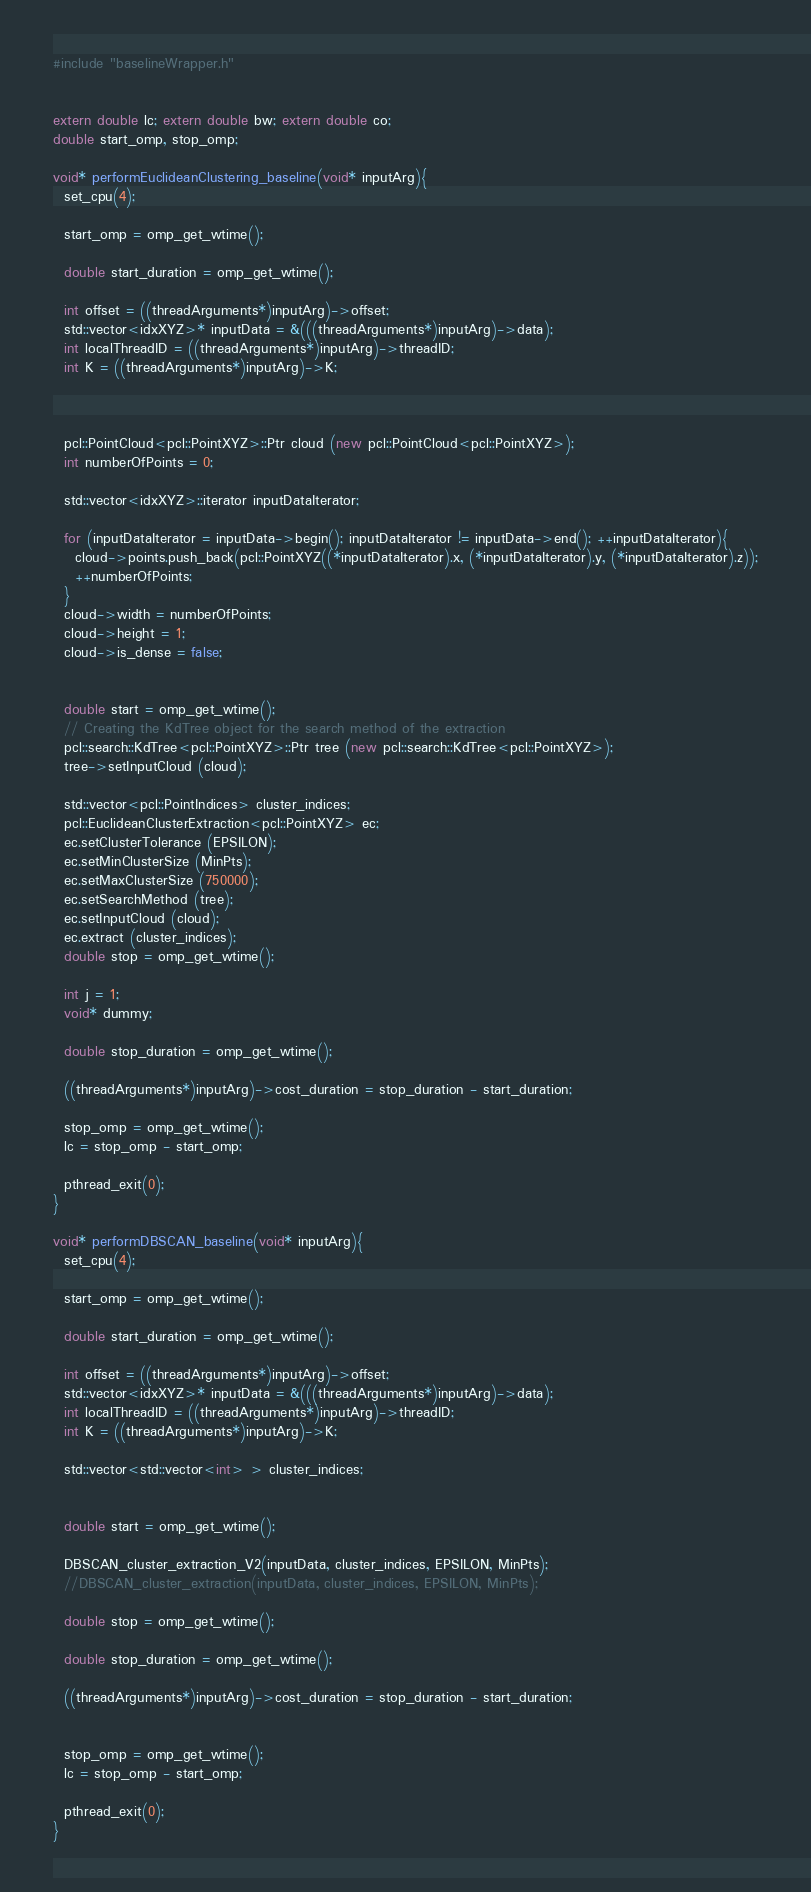Convert code to text. <code><loc_0><loc_0><loc_500><loc_500><_C++_>#include "baselineWrapper.h"


extern double lc; extern double bw; extern double co;
double start_omp, stop_omp;

void* performEuclideanClustering_baseline(void* inputArg){
  set_cpu(4);

  start_omp = omp_get_wtime();
  
  double start_duration = omp_get_wtime();
  
  int offset = ((threadArguments*)inputArg)->offset;
  std::vector<idxXYZ>* inputData = &(((threadArguments*)inputArg)->data);
  int localThreadID = ((threadArguments*)inputArg)->threadID;
  int K = ((threadArguments*)inputArg)->K;


  
  pcl::PointCloud<pcl::PointXYZ>::Ptr cloud (new pcl::PointCloud<pcl::PointXYZ>);
  int numberOfPoints = 0;

  std::vector<idxXYZ>::iterator inputDataIterator;

  for (inputDataIterator = inputData->begin(); inputDataIterator != inputData->end(); ++inputDataIterator){
    cloud->points.push_back(pcl::PointXYZ((*inputDataIterator).x, (*inputDataIterator).y, (*inputDataIterator).z));
    ++numberOfPoints;    
  }
  cloud->width = numberOfPoints; 
  cloud->height = 1;
  cloud->is_dense = false; 

  
  double start = omp_get_wtime();
  // Creating the KdTree object for the search method of the extraction
  pcl::search::KdTree<pcl::PointXYZ>::Ptr tree (new pcl::search::KdTree<pcl::PointXYZ>);
  tree->setInputCloud (cloud);

  std::vector<pcl::PointIndices> cluster_indices;
  pcl::EuclideanClusterExtraction<pcl::PointXYZ> ec;
  ec.setClusterTolerance (EPSILON);
  ec.setMinClusterSize (MinPts);
  ec.setMaxClusterSize (750000);
  ec.setSearchMethod (tree);
  ec.setInputCloud (cloud);
  ec.extract (cluster_indices);
  double stop = omp_get_wtime();

  int j = 1;
  void* dummy;

  double stop_duration = omp_get_wtime();

  ((threadArguments*)inputArg)->cost_duration = stop_duration - start_duration;

  stop_omp = omp_get_wtime();
  lc = stop_omp - start_omp;
  
  pthread_exit(0);
}

void* performDBSCAN_baseline(void* inputArg){
  set_cpu(4);
  
  start_omp = omp_get_wtime();
  
  double start_duration = omp_get_wtime();
  
  int offset = ((threadArguments*)inputArg)->offset;
  std::vector<idxXYZ>* inputData = &(((threadArguments*)inputArg)->data);
  int localThreadID = ((threadArguments*)inputArg)->threadID;
  int K = ((threadArguments*)inputArg)->K;

  std::vector<std::vector<int> > cluster_indices;

  
  double start = omp_get_wtime();

  DBSCAN_cluster_extraction_V2(inputData, cluster_indices, EPSILON, MinPts);
  //DBSCAN_cluster_extraction(inputData, cluster_indices, EPSILON, MinPts);
  
  double stop = omp_get_wtime();

  double stop_duration = omp_get_wtime();
  
  ((threadArguments*)inputArg)->cost_duration = stop_duration - start_duration;


  stop_omp = omp_get_wtime();
  lc = stop_omp - start_omp;
  
  pthread_exit(0);
}
</code> 